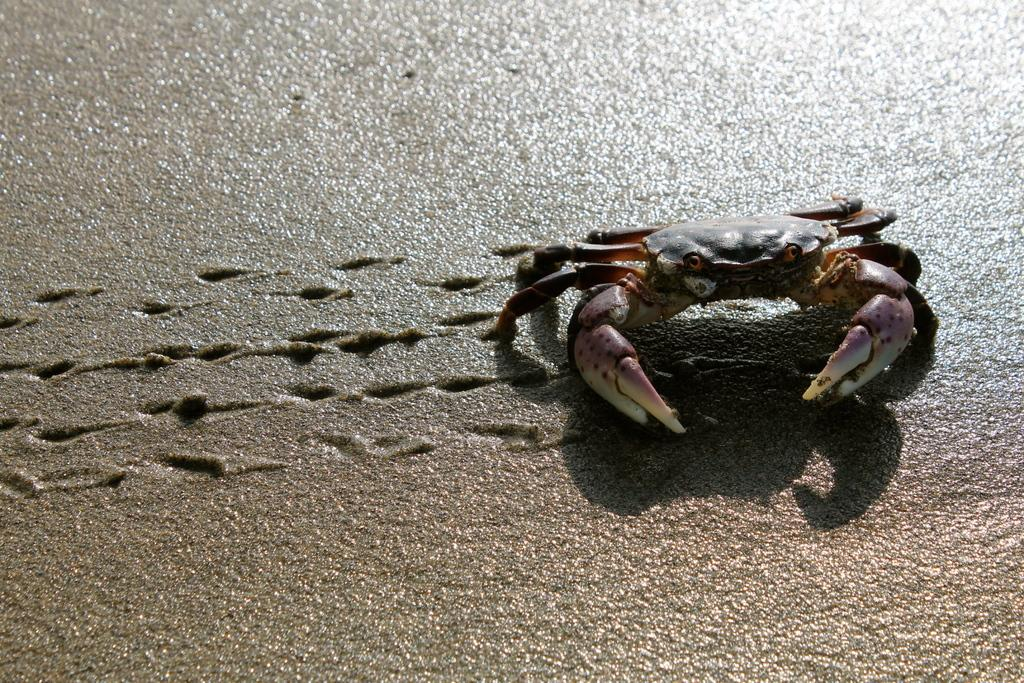What animal is present in the image? There is a crab in the image. Where is the crab located in the image? The crab is on the right side of the image. What type of terrain is visible in the background of the image? There is sand visible in the background of the image. Who is the porter meeting with in the image? There is no porter or meeting present in the image; it features a crab on the right side of the image with sand in the background. 